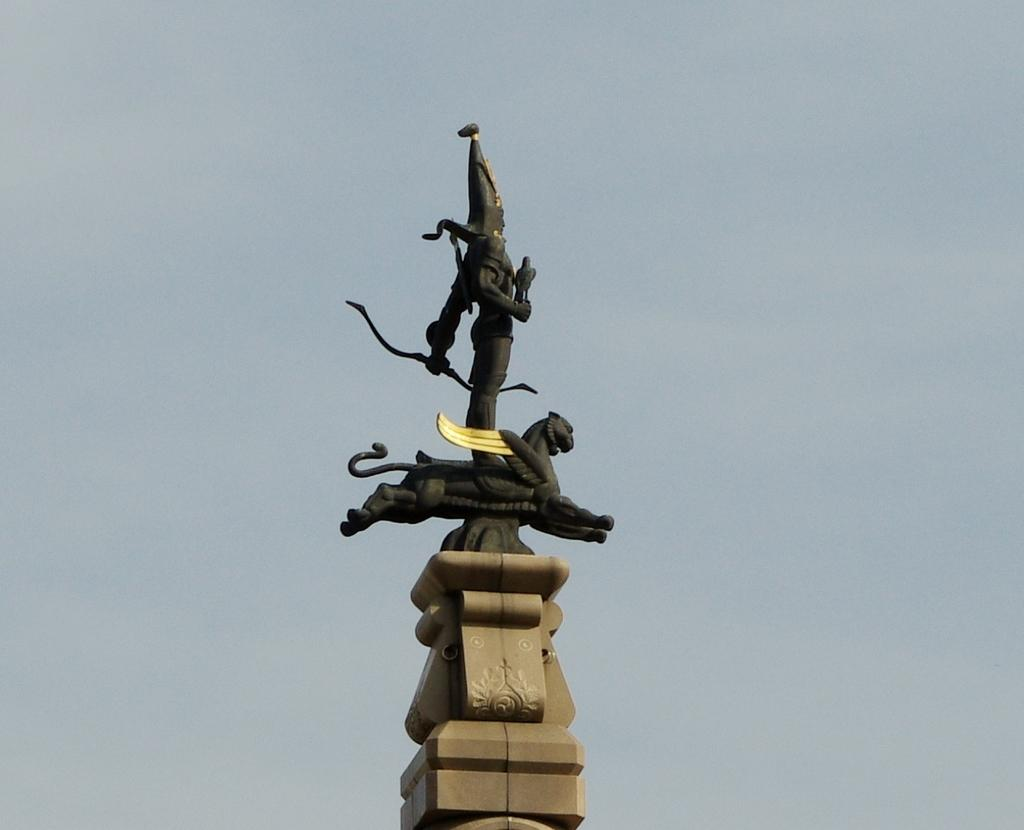What is the main subject of the image? The main subject of the image is a sculpture. What is the color of the sculpture? The sculpture is black in color. What else can be seen in the image besides the sculpture? The sky is visible in the image. What type of quartz can be seen in the image? There is no quartz present in the image; it features a black sculpture and the sky. What error can be seen in the image? There is no error present in the image; it is a clear depiction of a black sculpture and the sky. --- 